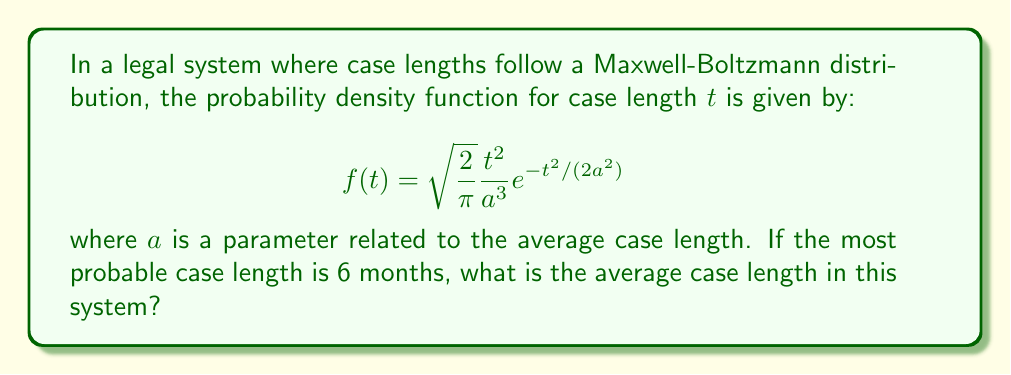Can you answer this question? To solve this problem, we'll follow these steps:

1) In the Maxwell-Boltzmann distribution, the most probable value (mode) is given by:

   $$ t_{mp} = \sqrt{2}a $$

2) We're given that the most probable case length is 6 months, so:

   $$ 6 = \sqrt{2}a $$

3) Solving for $a$:

   $$ a = \frac{6}{\sqrt{2}} = 3\sqrt{2} \text{ months} $$

4) In the Maxwell-Boltzmann distribution, the average (mean) value is related to $a$ by:

   $$ \langle t \rangle = \frac{2a}{\sqrt{\pi}} $$

5) Substituting our value for $a$:

   $$ \langle t \rangle = \frac{2(3\sqrt{2})}{\sqrt{\pi}} = \frac{6\sqrt{2}}{\sqrt{\pi}} \text{ months} $$

6) Simplifying:

   $$ \langle t \rangle = 6\sqrt{\frac{2}{\pi}} \approx 7.57 \text{ months} $$
Answer: $6\sqrt{\frac{2}{\pi}} \approx 7.57$ months 